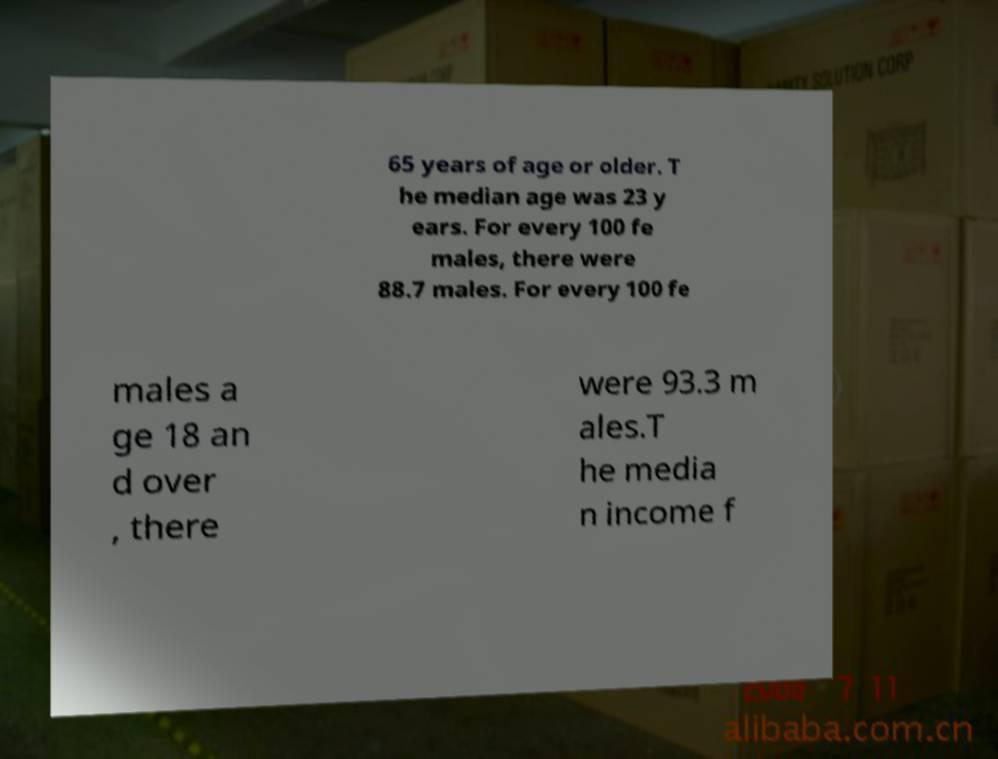Could you assist in decoding the text presented in this image and type it out clearly? 65 years of age or older. T he median age was 23 y ears. For every 100 fe males, there were 88.7 males. For every 100 fe males a ge 18 an d over , there were 93.3 m ales.T he media n income f 